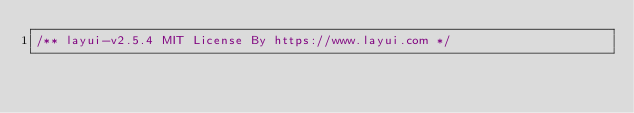<code> <loc_0><loc_0><loc_500><loc_500><_JavaScript_>/** layui-v2.5.4 MIT License By https://www.layui.com */</code> 